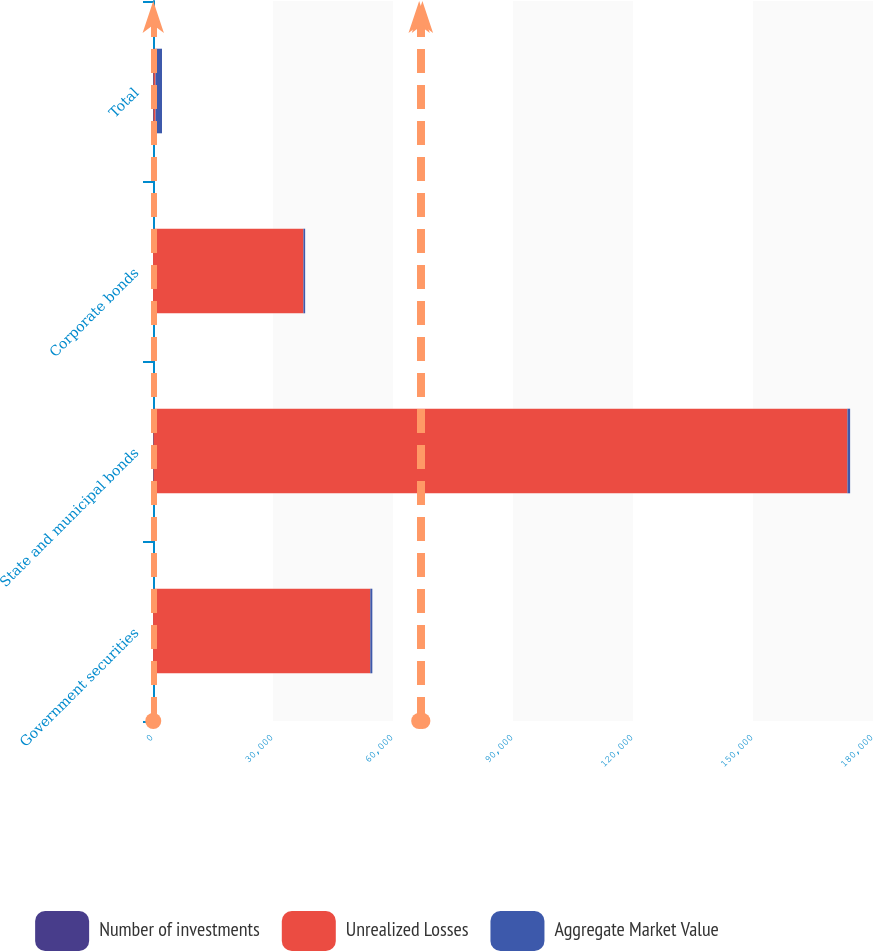<chart> <loc_0><loc_0><loc_500><loc_500><stacked_bar_chart><ecel><fcel>Government securities<fcel>State and municipal bonds<fcel>Corporate bonds<fcel>Total<nl><fcel>Number of investments<fcel>16<fcel>104<fcel>10<fcel>130<nl><fcel>Unrealized Losses<fcel>54313<fcel>173501<fcel>37596<fcel>505<nl><fcel>Aggregate Market Value<fcel>505<fcel>676<fcel>432<fcel>1613<nl></chart> 